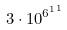<formula> <loc_0><loc_0><loc_500><loc_500>3 \cdot 1 0 ^ { { 6 ^ { 1 } } ^ { 1 } }</formula> 